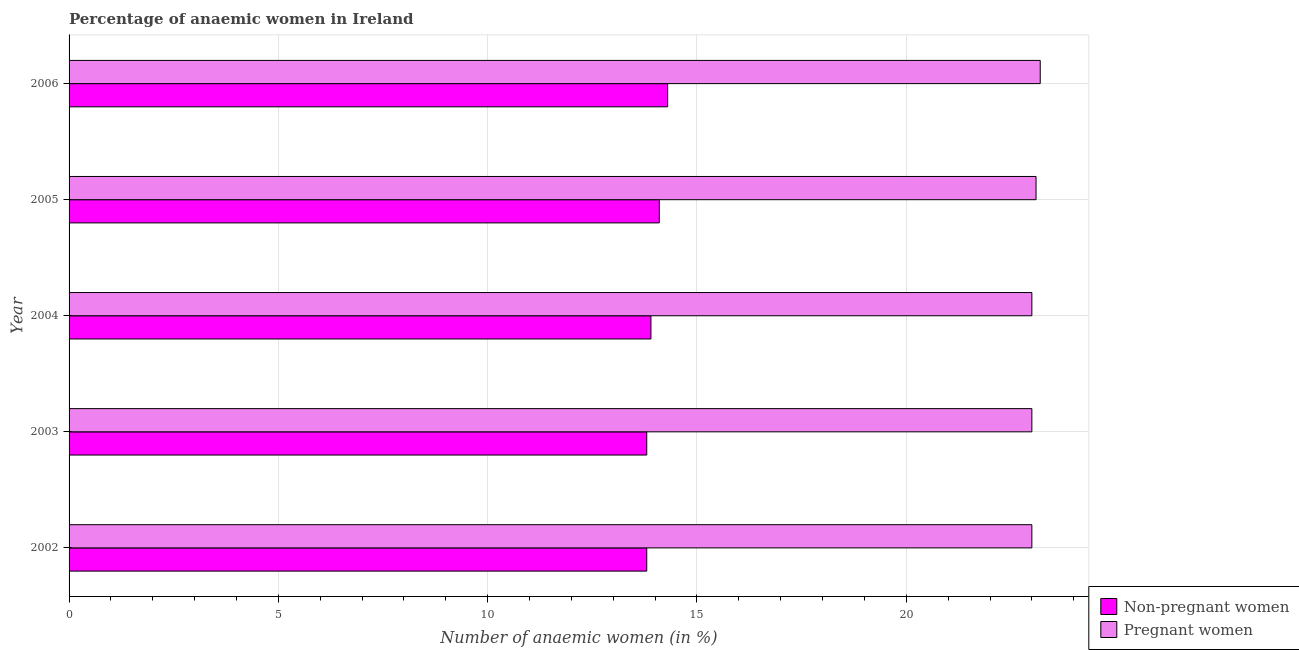How many different coloured bars are there?
Ensure brevity in your answer.  2. Are the number of bars on each tick of the Y-axis equal?
Ensure brevity in your answer.  Yes. How many bars are there on the 2nd tick from the top?
Make the answer very short. 2. How many bars are there on the 1st tick from the bottom?
Your response must be concise. 2. In how many cases, is the number of bars for a given year not equal to the number of legend labels?
Provide a short and direct response. 0. Across all years, what is the maximum percentage of pregnant anaemic women?
Your answer should be very brief. 23.2. In which year was the percentage of pregnant anaemic women maximum?
Your response must be concise. 2006. In which year was the percentage of pregnant anaemic women minimum?
Give a very brief answer. 2002. What is the total percentage of non-pregnant anaemic women in the graph?
Your answer should be compact. 69.9. What is the difference between the percentage of non-pregnant anaemic women in 2005 and that in 2006?
Give a very brief answer. -0.2. What is the difference between the percentage of pregnant anaemic women in 2005 and the percentage of non-pregnant anaemic women in 2003?
Your response must be concise. 9.3. What is the average percentage of pregnant anaemic women per year?
Your response must be concise. 23.06. In the year 2003, what is the difference between the percentage of pregnant anaemic women and percentage of non-pregnant anaemic women?
Your answer should be very brief. 9.2. In how many years, is the percentage of non-pregnant anaemic women greater than 22 %?
Offer a terse response. 0. What is the ratio of the percentage of non-pregnant anaemic women in 2005 to that in 2006?
Provide a short and direct response. 0.99. Is the percentage of pregnant anaemic women in 2002 less than that in 2003?
Your response must be concise. No. Is the difference between the percentage of pregnant anaemic women in 2002 and 2004 greater than the difference between the percentage of non-pregnant anaemic women in 2002 and 2004?
Your answer should be very brief. Yes. Is the sum of the percentage of pregnant anaemic women in 2002 and 2006 greater than the maximum percentage of non-pregnant anaemic women across all years?
Keep it short and to the point. Yes. What does the 1st bar from the top in 2006 represents?
Keep it short and to the point. Pregnant women. What does the 2nd bar from the bottom in 2004 represents?
Your answer should be compact. Pregnant women. How many bars are there?
Provide a succinct answer. 10. Does the graph contain any zero values?
Your answer should be compact. No. Where does the legend appear in the graph?
Your answer should be compact. Bottom right. How many legend labels are there?
Offer a terse response. 2. How are the legend labels stacked?
Ensure brevity in your answer.  Vertical. What is the title of the graph?
Provide a short and direct response. Percentage of anaemic women in Ireland. Does "Broad money growth" appear as one of the legend labels in the graph?
Provide a succinct answer. No. What is the label or title of the X-axis?
Offer a very short reply. Number of anaemic women (in %). What is the label or title of the Y-axis?
Make the answer very short. Year. What is the Number of anaemic women (in %) in Pregnant women in 2002?
Offer a terse response. 23. What is the Number of anaemic women (in %) of Non-pregnant women in 2004?
Make the answer very short. 13.9. What is the Number of anaemic women (in %) of Pregnant women in 2004?
Your response must be concise. 23. What is the Number of anaemic women (in %) of Pregnant women in 2005?
Offer a very short reply. 23.1. What is the Number of anaemic women (in %) of Non-pregnant women in 2006?
Your response must be concise. 14.3. What is the Number of anaemic women (in %) in Pregnant women in 2006?
Offer a very short reply. 23.2. Across all years, what is the maximum Number of anaemic women (in %) of Non-pregnant women?
Provide a succinct answer. 14.3. Across all years, what is the maximum Number of anaemic women (in %) in Pregnant women?
Give a very brief answer. 23.2. Across all years, what is the minimum Number of anaemic women (in %) of Pregnant women?
Offer a terse response. 23. What is the total Number of anaemic women (in %) in Non-pregnant women in the graph?
Offer a very short reply. 69.9. What is the total Number of anaemic women (in %) in Pregnant women in the graph?
Make the answer very short. 115.3. What is the difference between the Number of anaemic women (in %) of Non-pregnant women in 2002 and that in 2004?
Make the answer very short. -0.1. What is the difference between the Number of anaemic women (in %) in Pregnant women in 2002 and that in 2005?
Give a very brief answer. -0.1. What is the difference between the Number of anaemic women (in %) in Pregnant women in 2003 and that in 2004?
Make the answer very short. 0. What is the difference between the Number of anaemic women (in %) in Non-pregnant women in 2003 and that in 2005?
Ensure brevity in your answer.  -0.3. What is the difference between the Number of anaemic women (in %) of Pregnant women in 2003 and that in 2005?
Make the answer very short. -0.1. What is the difference between the Number of anaemic women (in %) in Non-pregnant women in 2003 and that in 2006?
Your response must be concise. -0.5. What is the difference between the Number of anaemic women (in %) of Pregnant women in 2003 and that in 2006?
Offer a very short reply. -0.2. What is the difference between the Number of anaemic women (in %) in Pregnant women in 2004 and that in 2005?
Keep it short and to the point. -0.1. What is the difference between the Number of anaemic women (in %) of Non-pregnant women in 2004 and that in 2006?
Provide a succinct answer. -0.4. What is the difference between the Number of anaemic women (in %) in Pregnant women in 2004 and that in 2006?
Your response must be concise. -0.2. What is the difference between the Number of anaemic women (in %) in Non-pregnant women in 2005 and that in 2006?
Your answer should be very brief. -0.2. What is the difference between the Number of anaemic women (in %) in Pregnant women in 2005 and that in 2006?
Keep it short and to the point. -0.1. What is the difference between the Number of anaemic women (in %) of Non-pregnant women in 2002 and the Number of anaemic women (in %) of Pregnant women in 2003?
Provide a short and direct response. -9.2. What is the difference between the Number of anaemic women (in %) in Non-pregnant women in 2002 and the Number of anaemic women (in %) in Pregnant women in 2005?
Provide a short and direct response. -9.3. What is the difference between the Number of anaemic women (in %) in Non-pregnant women in 2003 and the Number of anaemic women (in %) in Pregnant women in 2006?
Make the answer very short. -9.4. What is the average Number of anaemic women (in %) of Non-pregnant women per year?
Ensure brevity in your answer.  13.98. What is the average Number of anaemic women (in %) in Pregnant women per year?
Provide a succinct answer. 23.06. In the year 2002, what is the difference between the Number of anaemic women (in %) in Non-pregnant women and Number of anaemic women (in %) in Pregnant women?
Your response must be concise. -9.2. In the year 2004, what is the difference between the Number of anaemic women (in %) in Non-pregnant women and Number of anaemic women (in %) in Pregnant women?
Make the answer very short. -9.1. In the year 2005, what is the difference between the Number of anaemic women (in %) of Non-pregnant women and Number of anaemic women (in %) of Pregnant women?
Provide a succinct answer. -9. What is the ratio of the Number of anaemic women (in %) in Non-pregnant women in 2002 to that in 2004?
Give a very brief answer. 0.99. What is the ratio of the Number of anaemic women (in %) of Pregnant women in 2002 to that in 2004?
Provide a short and direct response. 1. What is the ratio of the Number of anaemic women (in %) of Non-pregnant women in 2002 to that in 2005?
Your answer should be very brief. 0.98. What is the ratio of the Number of anaemic women (in %) in Non-pregnant women in 2002 to that in 2006?
Ensure brevity in your answer.  0.96. What is the ratio of the Number of anaemic women (in %) in Pregnant women in 2002 to that in 2006?
Provide a succinct answer. 0.99. What is the ratio of the Number of anaemic women (in %) in Non-pregnant women in 2003 to that in 2004?
Offer a terse response. 0.99. What is the ratio of the Number of anaemic women (in %) of Pregnant women in 2003 to that in 2004?
Offer a terse response. 1. What is the ratio of the Number of anaemic women (in %) in Non-pregnant women in 2003 to that in 2005?
Provide a short and direct response. 0.98. What is the ratio of the Number of anaemic women (in %) of Pregnant women in 2003 to that in 2005?
Keep it short and to the point. 1. What is the ratio of the Number of anaemic women (in %) in Non-pregnant women in 2004 to that in 2005?
Keep it short and to the point. 0.99. What is the ratio of the Number of anaemic women (in %) in Pregnant women in 2004 to that in 2005?
Keep it short and to the point. 1. What is the ratio of the Number of anaemic women (in %) in Pregnant women in 2004 to that in 2006?
Ensure brevity in your answer.  0.99. What is the ratio of the Number of anaemic women (in %) of Non-pregnant women in 2005 to that in 2006?
Keep it short and to the point. 0.99. What is the ratio of the Number of anaemic women (in %) in Pregnant women in 2005 to that in 2006?
Offer a very short reply. 1. What is the difference between the highest and the second highest Number of anaemic women (in %) of Pregnant women?
Offer a terse response. 0.1. 